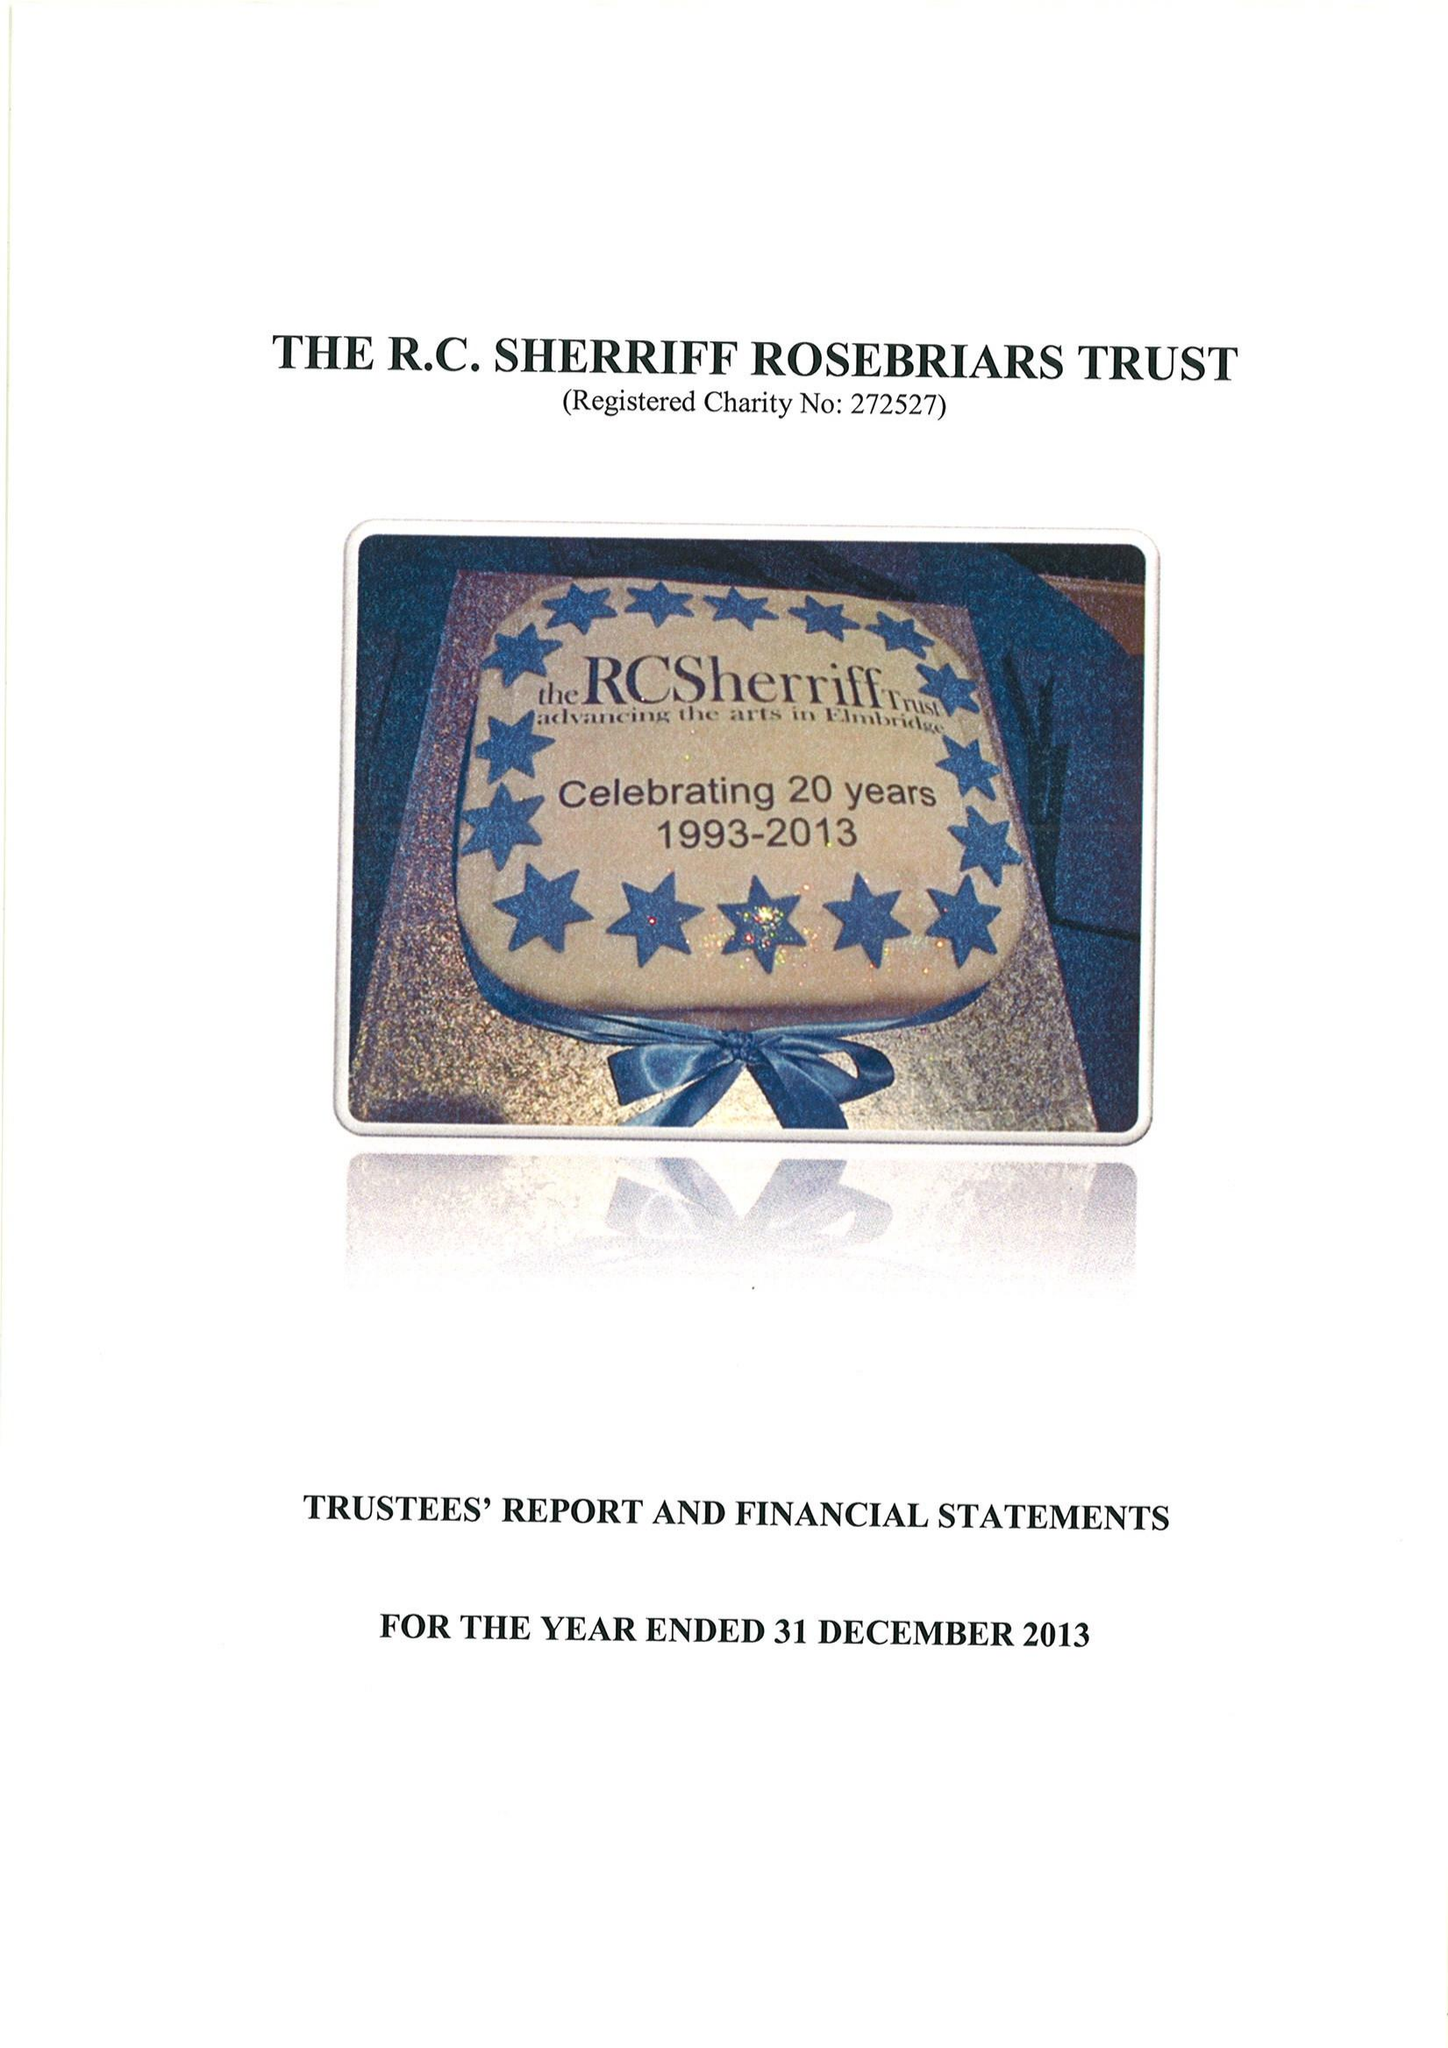What is the value for the income_annually_in_british_pounds?
Answer the question using a single word or phrase. 186093.00 